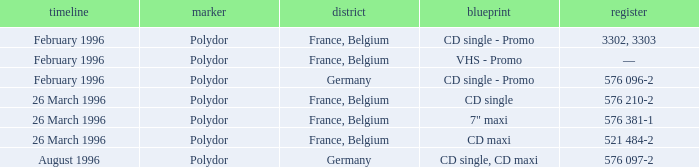Can you parse all the data within this table? {'header': ['timeline', 'marker', 'district', 'blueprint', 'register'], 'rows': [['February 1996', 'Polydor', 'France, Belgium', 'CD single - Promo', '3302, 3303'], ['February 1996', 'Polydor', 'France, Belgium', 'VHS - Promo', '—'], ['February 1996', 'Polydor', 'Germany', 'CD single - Promo', '576 096-2'], ['26 March 1996', 'Polydor', 'France, Belgium', 'CD single', '576 210-2'], ['26 March 1996', 'Polydor', 'France, Belgium', '7" maxi', '576 381-1'], ['26 March 1996', 'Polydor', 'France, Belgium', 'CD maxi', '521 484-2'], ['August 1996', 'Polydor', 'Germany', 'CD single, CD maxi', '576 097-2']]} Name the region with catalog of 576 097-2 Germany. 